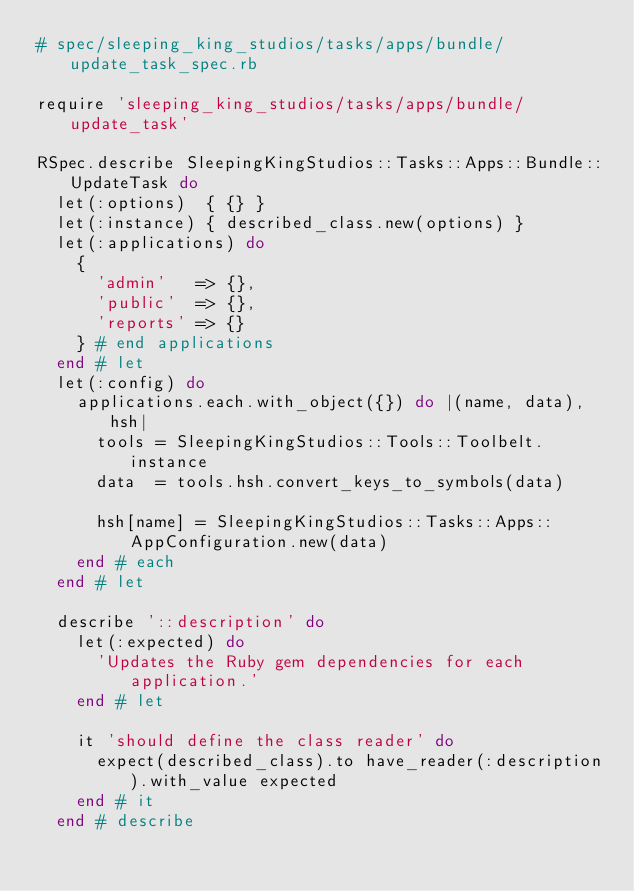<code> <loc_0><loc_0><loc_500><loc_500><_Ruby_># spec/sleeping_king_studios/tasks/apps/bundle/update_task_spec.rb

require 'sleeping_king_studios/tasks/apps/bundle/update_task'

RSpec.describe SleepingKingStudios::Tasks::Apps::Bundle::UpdateTask do
  let(:options)  { {} }
  let(:instance) { described_class.new(options) }
  let(:applications) do
    {
      'admin'   => {},
      'public'  => {},
      'reports' => {}
    } # end applications
  end # let
  let(:config) do
    applications.each.with_object({}) do |(name, data), hsh|
      tools = SleepingKingStudios::Tools::Toolbelt.instance
      data  = tools.hsh.convert_keys_to_symbols(data)

      hsh[name] = SleepingKingStudios::Tasks::Apps::AppConfiguration.new(data)
    end # each
  end # let

  describe '::description' do
    let(:expected) do
      'Updates the Ruby gem dependencies for each application.'
    end # let

    it 'should define the class reader' do
      expect(described_class).to have_reader(:description).with_value expected
    end # it
  end # describe
</code> 